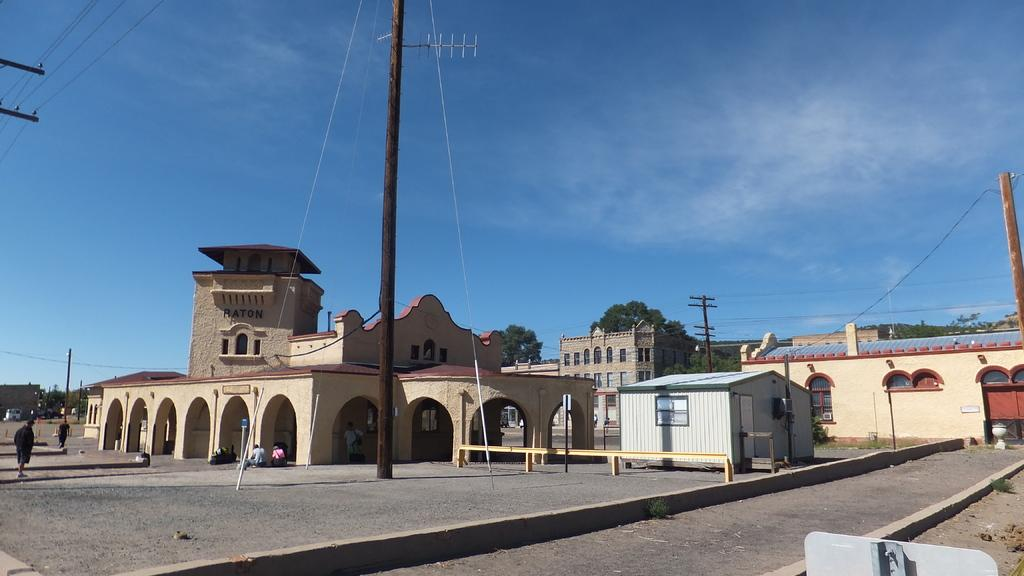What can be seen in the foreground of the image? There is a path and a board in the foreground of the image. What is visible in the background of the image? There are buildings, poles, trees, cables, and the sky in the background of the image. Can you describe the sky in the image? The sky is visible in the background of the image, and there is a cloud present. How many trucks are parked on the hill in the image? There is no hill or trucks present in the image. What is the height of the drop from the top of the pole to the ground in the image? There is no drop or pole present in the image. 